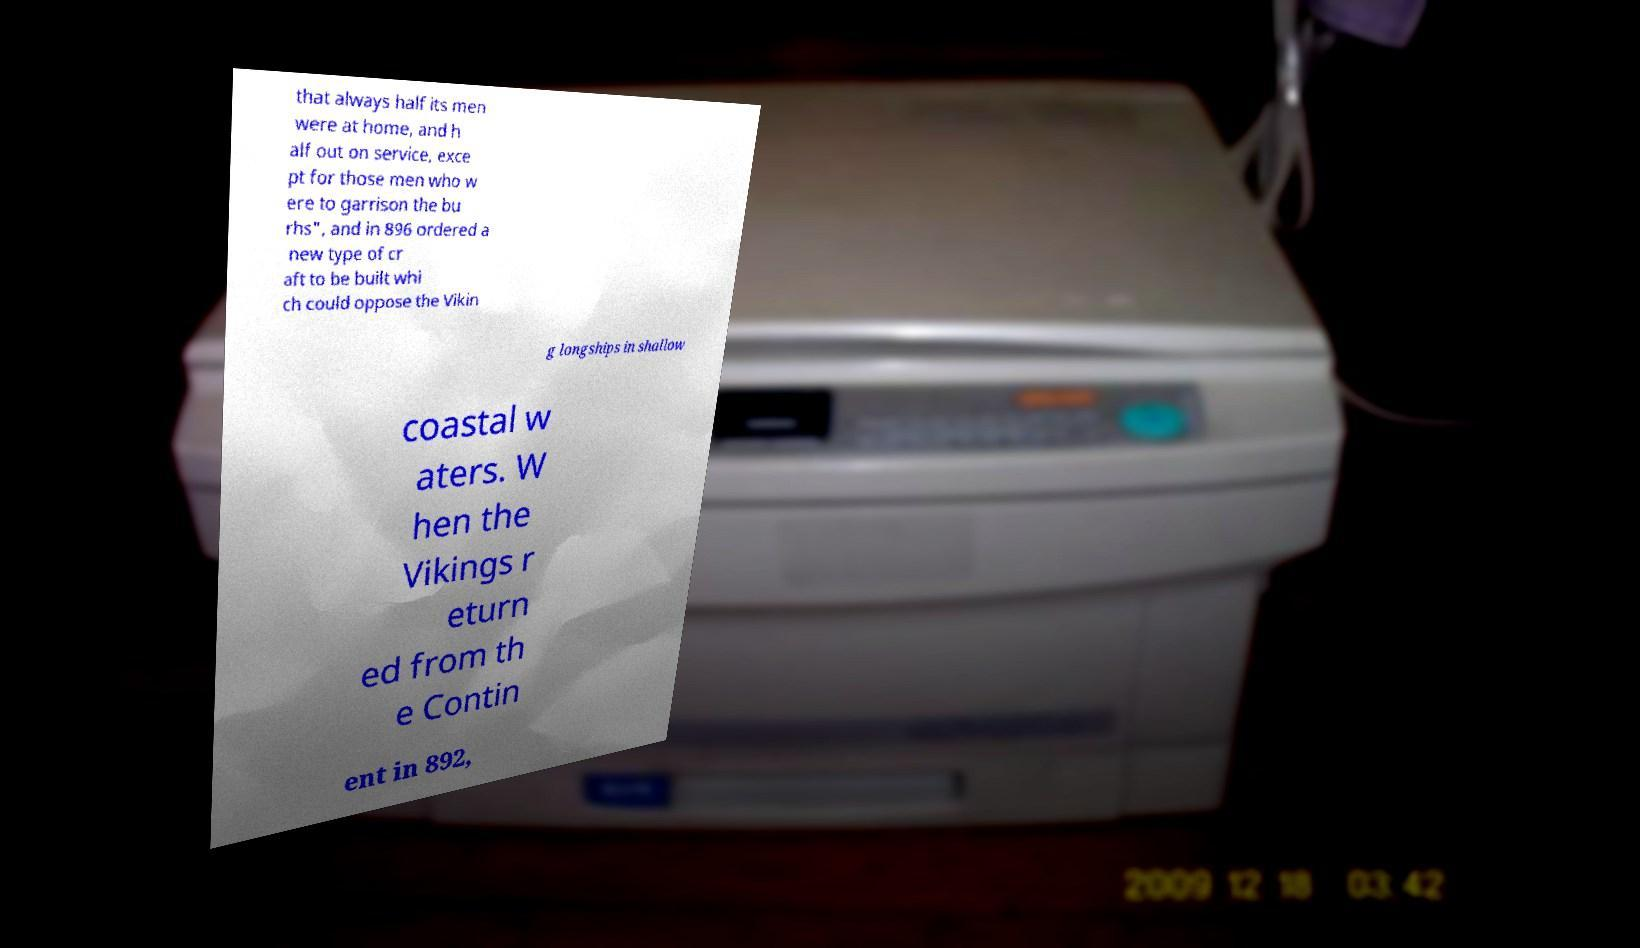There's text embedded in this image that I need extracted. Can you transcribe it verbatim? that always half its men were at home, and h alf out on service, exce pt for those men who w ere to garrison the bu rhs", and in 896 ordered a new type of cr aft to be built whi ch could oppose the Vikin g longships in shallow coastal w aters. W hen the Vikings r eturn ed from th e Contin ent in 892, 